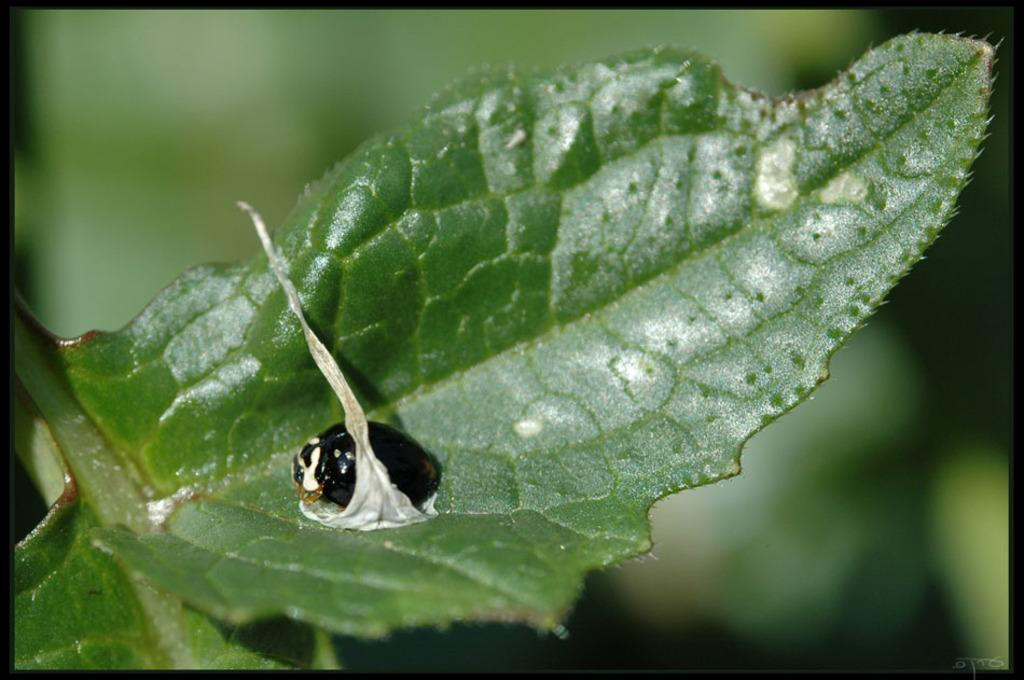What is present in the image? There is an insect in the image. Where is the insect located? The insect is sitting on a leaf. What type of can does the insect have in the image? There is no can present in the image; the insect is sitting on a leaf. Does the insect have a tail in the image? Insects do not have tails, so there is no tail present in the image. 